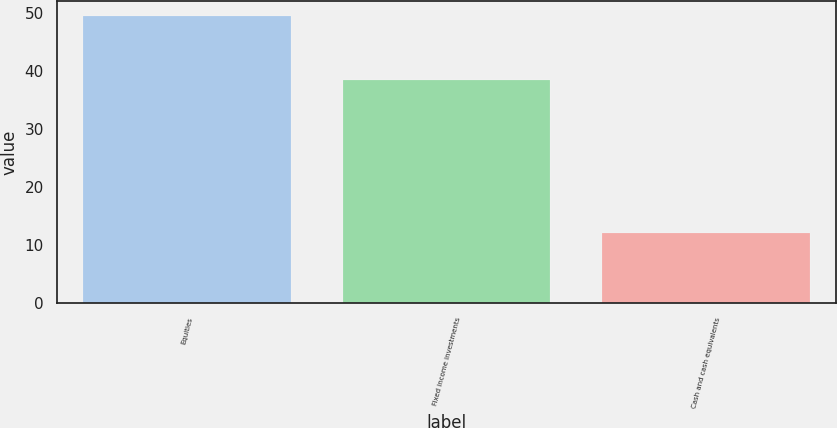<chart> <loc_0><loc_0><loc_500><loc_500><bar_chart><fcel>Equities<fcel>Fixed income investments<fcel>Cash and cash equivalents<nl><fcel>49.5<fcel>38.4<fcel>12.1<nl></chart> 